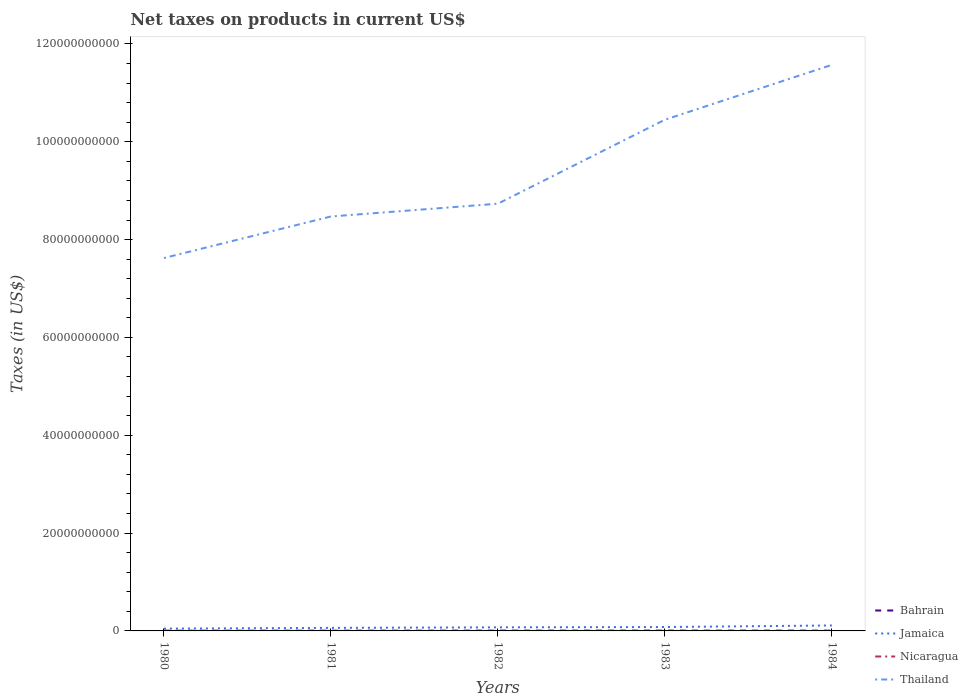Is the number of lines equal to the number of legend labels?
Your answer should be compact. Yes. Across all years, what is the maximum net taxes on products in Jamaica?
Keep it short and to the point. 4.69e+08. In which year was the net taxes on products in Bahrain maximum?
Your answer should be very brief. 1980. What is the total net taxes on products in Thailand in the graph?
Ensure brevity in your answer.  -2.84e+1. What is the difference between the highest and the second highest net taxes on products in Bahrain?
Offer a very short reply. 2.24e+07. Is the net taxes on products in Nicaragua strictly greater than the net taxes on products in Thailand over the years?
Give a very brief answer. Yes. What is the difference between two consecutive major ticks on the Y-axis?
Your answer should be very brief. 2.00e+1. Are the values on the major ticks of Y-axis written in scientific E-notation?
Offer a very short reply. No. Where does the legend appear in the graph?
Ensure brevity in your answer.  Bottom right. What is the title of the graph?
Your response must be concise. Net taxes on products in current US$. What is the label or title of the X-axis?
Your answer should be compact. Years. What is the label or title of the Y-axis?
Make the answer very short. Taxes (in US$). What is the Taxes (in US$) of Bahrain in 1980?
Keep it short and to the point. 4.03e+07. What is the Taxes (in US$) of Jamaica in 1980?
Give a very brief answer. 4.69e+08. What is the Taxes (in US$) of Nicaragua in 1980?
Your answer should be very brief. 0.15. What is the Taxes (in US$) of Thailand in 1980?
Provide a succinct answer. 7.62e+1. What is the Taxes (in US$) of Bahrain in 1981?
Offer a terse response. 5.02e+07. What is the Taxes (in US$) in Jamaica in 1981?
Your answer should be compact. 6.22e+08. What is the Taxes (in US$) of Nicaragua in 1981?
Ensure brevity in your answer.  0.54. What is the Taxes (in US$) in Thailand in 1981?
Your answer should be compact. 8.47e+1. What is the Taxes (in US$) in Bahrain in 1982?
Your answer should be very brief. 6.04e+07. What is the Taxes (in US$) in Jamaica in 1982?
Keep it short and to the point. 7.32e+08. What is the Taxes (in US$) in Nicaragua in 1982?
Keep it short and to the point. 0.74. What is the Taxes (in US$) of Thailand in 1982?
Your response must be concise. 8.73e+1. What is the Taxes (in US$) of Bahrain in 1983?
Your answer should be very brief. 6.27e+07. What is the Taxes (in US$) in Jamaica in 1983?
Keep it short and to the point. 7.94e+08. What is the Taxes (in US$) of Nicaragua in 1983?
Your answer should be very brief. 1.15. What is the Taxes (in US$) of Thailand in 1983?
Provide a succinct answer. 1.05e+11. What is the Taxes (in US$) in Bahrain in 1984?
Keep it short and to the point. 5.85e+07. What is the Taxes (in US$) of Jamaica in 1984?
Provide a succinct answer. 1.11e+09. What is the Taxes (in US$) of Nicaragua in 1984?
Provide a short and direct response. 1.9. What is the Taxes (in US$) in Thailand in 1984?
Your response must be concise. 1.16e+11. Across all years, what is the maximum Taxes (in US$) of Bahrain?
Provide a short and direct response. 6.27e+07. Across all years, what is the maximum Taxes (in US$) in Jamaica?
Keep it short and to the point. 1.11e+09. Across all years, what is the maximum Taxes (in US$) in Nicaragua?
Offer a terse response. 1.9. Across all years, what is the maximum Taxes (in US$) in Thailand?
Ensure brevity in your answer.  1.16e+11. Across all years, what is the minimum Taxes (in US$) in Bahrain?
Offer a terse response. 4.03e+07. Across all years, what is the minimum Taxes (in US$) of Jamaica?
Your answer should be very brief. 4.69e+08. Across all years, what is the minimum Taxes (in US$) in Nicaragua?
Offer a terse response. 0.15. Across all years, what is the minimum Taxes (in US$) of Thailand?
Offer a very short reply. 7.62e+1. What is the total Taxes (in US$) in Bahrain in the graph?
Your answer should be compact. 2.72e+08. What is the total Taxes (in US$) of Jamaica in the graph?
Offer a very short reply. 3.73e+09. What is the total Taxes (in US$) of Nicaragua in the graph?
Your answer should be compact. 4.48. What is the total Taxes (in US$) in Thailand in the graph?
Give a very brief answer. 4.69e+11. What is the difference between the Taxes (in US$) in Bahrain in 1980 and that in 1981?
Provide a short and direct response. -9.90e+06. What is the difference between the Taxes (in US$) in Jamaica in 1980 and that in 1981?
Keep it short and to the point. -1.53e+08. What is the difference between the Taxes (in US$) of Nicaragua in 1980 and that in 1981?
Your response must be concise. -0.39. What is the difference between the Taxes (in US$) in Thailand in 1980 and that in 1981?
Offer a terse response. -8.49e+09. What is the difference between the Taxes (in US$) in Bahrain in 1980 and that in 1982?
Provide a succinct answer. -2.01e+07. What is the difference between the Taxes (in US$) in Jamaica in 1980 and that in 1982?
Make the answer very short. -2.64e+08. What is the difference between the Taxes (in US$) in Nicaragua in 1980 and that in 1982?
Provide a short and direct response. -0.59. What is the difference between the Taxes (in US$) of Thailand in 1980 and that in 1982?
Provide a succinct answer. -1.11e+1. What is the difference between the Taxes (in US$) of Bahrain in 1980 and that in 1983?
Provide a short and direct response. -2.24e+07. What is the difference between the Taxes (in US$) of Jamaica in 1980 and that in 1983?
Offer a terse response. -3.26e+08. What is the difference between the Taxes (in US$) of Nicaragua in 1980 and that in 1983?
Make the answer very short. -1. What is the difference between the Taxes (in US$) of Thailand in 1980 and that in 1983?
Provide a short and direct response. -2.83e+1. What is the difference between the Taxes (in US$) in Bahrain in 1980 and that in 1984?
Your answer should be very brief. -1.82e+07. What is the difference between the Taxes (in US$) of Jamaica in 1980 and that in 1984?
Your answer should be compact. -6.46e+08. What is the difference between the Taxes (in US$) in Nicaragua in 1980 and that in 1984?
Offer a very short reply. -1.76. What is the difference between the Taxes (in US$) of Thailand in 1980 and that in 1984?
Ensure brevity in your answer.  -3.95e+1. What is the difference between the Taxes (in US$) of Bahrain in 1981 and that in 1982?
Your answer should be very brief. -1.02e+07. What is the difference between the Taxes (in US$) of Jamaica in 1981 and that in 1982?
Make the answer very short. -1.10e+08. What is the difference between the Taxes (in US$) of Nicaragua in 1981 and that in 1982?
Provide a short and direct response. -0.2. What is the difference between the Taxes (in US$) in Thailand in 1981 and that in 1982?
Ensure brevity in your answer.  -2.61e+09. What is the difference between the Taxes (in US$) in Bahrain in 1981 and that in 1983?
Keep it short and to the point. -1.25e+07. What is the difference between the Taxes (in US$) of Jamaica in 1981 and that in 1983?
Your response must be concise. -1.72e+08. What is the difference between the Taxes (in US$) of Nicaragua in 1981 and that in 1983?
Keep it short and to the point. -0.61. What is the difference between the Taxes (in US$) in Thailand in 1981 and that in 1983?
Keep it short and to the point. -1.98e+1. What is the difference between the Taxes (in US$) of Bahrain in 1981 and that in 1984?
Provide a succinct answer. -8.30e+06. What is the difference between the Taxes (in US$) in Jamaica in 1981 and that in 1984?
Your answer should be compact. -4.92e+08. What is the difference between the Taxes (in US$) in Nicaragua in 1981 and that in 1984?
Ensure brevity in your answer.  -1.36. What is the difference between the Taxes (in US$) in Thailand in 1981 and that in 1984?
Keep it short and to the point. -3.10e+1. What is the difference between the Taxes (in US$) in Bahrain in 1982 and that in 1983?
Offer a terse response. -2.30e+06. What is the difference between the Taxes (in US$) of Jamaica in 1982 and that in 1983?
Provide a succinct answer. -6.23e+07. What is the difference between the Taxes (in US$) in Nicaragua in 1982 and that in 1983?
Provide a succinct answer. -0.41. What is the difference between the Taxes (in US$) in Thailand in 1982 and that in 1983?
Give a very brief answer. -1.72e+1. What is the difference between the Taxes (in US$) of Bahrain in 1982 and that in 1984?
Ensure brevity in your answer.  1.90e+06. What is the difference between the Taxes (in US$) of Jamaica in 1982 and that in 1984?
Ensure brevity in your answer.  -3.82e+08. What is the difference between the Taxes (in US$) in Nicaragua in 1982 and that in 1984?
Your response must be concise. -1.16. What is the difference between the Taxes (in US$) in Thailand in 1982 and that in 1984?
Your answer should be very brief. -2.84e+1. What is the difference between the Taxes (in US$) in Bahrain in 1983 and that in 1984?
Give a very brief answer. 4.20e+06. What is the difference between the Taxes (in US$) in Jamaica in 1983 and that in 1984?
Your answer should be very brief. -3.20e+08. What is the difference between the Taxes (in US$) in Nicaragua in 1983 and that in 1984?
Ensure brevity in your answer.  -0.75. What is the difference between the Taxes (in US$) in Thailand in 1983 and that in 1984?
Provide a succinct answer. -1.12e+1. What is the difference between the Taxes (in US$) in Bahrain in 1980 and the Taxes (in US$) in Jamaica in 1981?
Keep it short and to the point. -5.82e+08. What is the difference between the Taxes (in US$) in Bahrain in 1980 and the Taxes (in US$) in Nicaragua in 1981?
Offer a very short reply. 4.03e+07. What is the difference between the Taxes (in US$) in Bahrain in 1980 and the Taxes (in US$) in Thailand in 1981?
Provide a short and direct response. -8.47e+1. What is the difference between the Taxes (in US$) of Jamaica in 1980 and the Taxes (in US$) of Nicaragua in 1981?
Your answer should be very brief. 4.69e+08. What is the difference between the Taxes (in US$) of Jamaica in 1980 and the Taxes (in US$) of Thailand in 1981?
Make the answer very short. -8.43e+1. What is the difference between the Taxes (in US$) of Nicaragua in 1980 and the Taxes (in US$) of Thailand in 1981?
Your response must be concise. -8.47e+1. What is the difference between the Taxes (in US$) in Bahrain in 1980 and the Taxes (in US$) in Jamaica in 1982?
Offer a very short reply. -6.92e+08. What is the difference between the Taxes (in US$) of Bahrain in 1980 and the Taxes (in US$) of Nicaragua in 1982?
Provide a succinct answer. 4.03e+07. What is the difference between the Taxes (in US$) in Bahrain in 1980 and the Taxes (in US$) in Thailand in 1982?
Provide a short and direct response. -8.73e+1. What is the difference between the Taxes (in US$) of Jamaica in 1980 and the Taxes (in US$) of Nicaragua in 1982?
Ensure brevity in your answer.  4.69e+08. What is the difference between the Taxes (in US$) of Jamaica in 1980 and the Taxes (in US$) of Thailand in 1982?
Ensure brevity in your answer.  -8.69e+1. What is the difference between the Taxes (in US$) in Nicaragua in 1980 and the Taxes (in US$) in Thailand in 1982?
Keep it short and to the point. -8.73e+1. What is the difference between the Taxes (in US$) in Bahrain in 1980 and the Taxes (in US$) in Jamaica in 1983?
Give a very brief answer. -7.54e+08. What is the difference between the Taxes (in US$) in Bahrain in 1980 and the Taxes (in US$) in Nicaragua in 1983?
Offer a very short reply. 4.03e+07. What is the difference between the Taxes (in US$) in Bahrain in 1980 and the Taxes (in US$) in Thailand in 1983?
Your answer should be very brief. -1.04e+11. What is the difference between the Taxes (in US$) of Jamaica in 1980 and the Taxes (in US$) of Nicaragua in 1983?
Provide a short and direct response. 4.69e+08. What is the difference between the Taxes (in US$) of Jamaica in 1980 and the Taxes (in US$) of Thailand in 1983?
Offer a terse response. -1.04e+11. What is the difference between the Taxes (in US$) in Nicaragua in 1980 and the Taxes (in US$) in Thailand in 1983?
Make the answer very short. -1.05e+11. What is the difference between the Taxes (in US$) in Bahrain in 1980 and the Taxes (in US$) in Jamaica in 1984?
Make the answer very short. -1.07e+09. What is the difference between the Taxes (in US$) in Bahrain in 1980 and the Taxes (in US$) in Nicaragua in 1984?
Offer a terse response. 4.03e+07. What is the difference between the Taxes (in US$) of Bahrain in 1980 and the Taxes (in US$) of Thailand in 1984?
Provide a short and direct response. -1.16e+11. What is the difference between the Taxes (in US$) of Jamaica in 1980 and the Taxes (in US$) of Nicaragua in 1984?
Provide a succinct answer. 4.69e+08. What is the difference between the Taxes (in US$) in Jamaica in 1980 and the Taxes (in US$) in Thailand in 1984?
Offer a very short reply. -1.15e+11. What is the difference between the Taxes (in US$) of Nicaragua in 1980 and the Taxes (in US$) of Thailand in 1984?
Your response must be concise. -1.16e+11. What is the difference between the Taxes (in US$) of Bahrain in 1981 and the Taxes (in US$) of Jamaica in 1982?
Make the answer very short. -6.82e+08. What is the difference between the Taxes (in US$) in Bahrain in 1981 and the Taxes (in US$) in Nicaragua in 1982?
Your answer should be very brief. 5.02e+07. What is the difference between the Taxes (in US$) of Bahrain in 1981 and the Taxes (in US$) of Thailand in 1982?
Give a very brief answer. -8.73e+1. What is the difference between the Taxes (in US$) in Jamaica in 1981 and the Taxes (in US$) in Nicaragua in 1982?
Your answer should be very brief. 6.22e+08. What is the difference between the Taxes (in US$) of Jamaica in 1981 and the Taxes (in US$) of Thailand in 1982?
Offer a very short reply. -8.67e+1. What is the difference between the Taxes (in US$) in Nicaragua in 1981 and the Taxes (in US$) in Thailand in 1982?
Provide a succinct answer. -8.73e+1. What is the difference between the Taxes (in US$) of Bahrain in 1981 and the Taxes (in US$) of Jamaica in 1983?
Provide a succinct answer. -7.44e+08. What is the difference between the Taxes (in US$) in Bahrain in 1981 and the Taxes (in US$) in Nicaragua in 1983?
Ensure brevity in your answer.  5.02e+07. What is the difference between the Taxes (in US$) of Bahrain in 1981 and the Taxes (in US$) of Thailand in 1983?
Ensure brevity in your answer.  -1.04e+11. What is the difference between the Taxes (in US$) of Jamaica in 1981 and the Taxes (in US$) of Nicaragua in 1983?
Make the answer very short. 6.22e+08. What is the difference between the Taxes (in US$) of Jamaica in 1981 and the Taxes (in US$) of Thailand in 1983?
Keep it short and to the point. -1.04e+11. What is the difference between the Taxes (in US$) in Nicaragua in 1981 and the Taxes (in US$) in Thailand in 1983?
Your answer should be compact. -1.05e+11. What is the difference between the Taxes (in US$) in Bahrain in 1981 and the Taxes (in US$) in Jamaica in 1984?
Your answer should be compact. -1.06e+09. What is the difference between the Taxes (in US$) in Bahrain in 1981 and the Taxes (in US$) in Nicaragua in 1984?
Offer a very short reply. 5.02e+07. What is the difference between the Taxes (in US$) of Bahrain in 1981 and the Taxes (in US$) of Thailand in 1984?
Offer a very short reply. -1.16e+11. What is the difference between the Taxes (in US$) of Jamaica in 1981 and the Taxes (in US$) of Nicaragua in 1984?
Offer a terse response. 6.22e+08. What is the difference between the Taxes (in US$) of Jamaica in 1981 and the Taxes (in US$) of Thailand in 1984?
Offer a very short reply. -1.15e+11. What is the difference between the Taxes (in US$) in Nicaragua in 1981 and the Taxes (in US$) in Thailand in 1984?
Your answer should be compact. -1.16e+11. What is the difference between the Taxes (in US$) in Bahrain in 1982 and the Taxes (in US$) in Jamaica in 1983?
Make the answer very short. -7.34e+08. What is the difference between the Taxes (in US$) in Bahrain in 1982 and the Taxes (in US$) in Nicaragua in 1983?
Your answer should be compact. 6.04e+07. What is the difference between the Taxes (in US$) of Bahrain in 1982 and the Taxes (in US$) of Thailand in 1983?
Keep it short and to the point. -1.04e+11. What is the difference between the Taxes (in US$) of Jamaica in 1982 and the Taxes (in US$) of Nicaragua in 1983?
Your response must be concise. 7.32e+08. What is the difference between the Taxes (in US$) of Jamaica in 1982 and the Taxes (in US$) of Thailand in 1983?
Provide a succinct answer. -1.04e+11. What is the difference between the Taxes (in US$) in Nicaragua in 1982 and the Taxes (in US$) in Thailand in 1983?
Offer a very short reply. -1.05e+11. What is the difference between the Taxes (in US$) of Bahrain in 1982 and the Taxes (in US$) of Jamaica in 1984?
Offer a very short reply. -1.05e+09. What is the difference between the Taxes (in US$) of Bahrain in 1982 and the Taxes (in US$) of Nicaragua in 1984?
Provide a succinct answer. 6.04e+07. What is the difference between the Taxes (in US$) of Bahrain in 1982 and the Taxes (in US$) of Thailand in 1984?
Give a very brief answer. -1.16e+11. What is the difference between the Taxes (in US$) in Jamaica in 1982 and the Taxes (in US$) in Nicaragua in 1984?
Offer a terse response. 7.32e+08. What is the difference between the Taxes (in US$) in Jamaica in 1982 and the Taxes (in US$) in Thailand in 1984?
Provide a succinct answer. -1.15e+11. What is the difference between the Taxes (in US$) of Nicaragua in 1982 and the Taxes (in US$) of Thailand in 1984?
Provide a short and direct response. -1.16e+11. What is the difference between the Taxes (in US$) in Bahrain in 1983 and the Taxes (in US$) in Jamaica in 1984?
Provide a short and direct response. -1.05e+09. What is the difference between the Taxes (in US$) of Bahrain in 1983 and the Taxes (in US$) of Nicaragua in 1984?
Offer a very short reply. 6.27e+07. What is the difference between the Taxes (in US$) of Bahrain in 1983 and the Taxes (in US$) of Thailand in 1984?
Your answer should be compact. -1.16e+11. What is the difference between the Taxes (in US$) of Jamaica in 1983 and the Taxes (in US$) of Nicaragua in 1984?
Offer a very short reply. 7.94e+08. What is the difference between the Taxes (in US$) in Jamaica in 1983 and the Taxes (in US$) in Thailand in 1984?
Give a very brief answer. -1.15e+11. What is the difference between the Taxes (in US$) in Nicaragua in 1983 and the Taxes (in US$) in Thailand in 1984?
Your response must be concise. -1.16e+11. What is the average Taxes (in US$) in Bahrain per year?
Ensure brevity in your answer.  5.44e+07. What is the average Taxes (in US$) of Jamaica per year?
Your answer should be compact. 7.46e+08. What is the average Taxes (in US$) in Nicaragua per year?
Keep it short and to the point. 0.9. What is the average Taxes (in US$) of Thailand per year?
Provide a short and direct response. 9.37e+1. In the year 1980, what is the difference between the Taxes (in US$) of Bahrain and Taxes (in US$) of Jamaica?
Provide a short and direct response. -4.28e+08. In the year 1980, what is the difference between the Taxes (in US$) of Bahrain and Taxes (in US$) of Nicaragua?
Offer a very short reply. 4.03e+07. In the year 1980, what is the difference between the Taxes (in US$) of Bahrain and Taxes (in US$) of Thailand?
Keep it short and to the point. -7.62e+1. In the year 1980, what is the difference between the Taxes (in US$) in Jamaica and Taxes (in US$) in Nicaragua?
Keep it short and to the point. 4.69e+08. In the year 1980, what is the difference between the Taxes (in US$) of Jamaica and Taxes (in US$) of Thailand?
Offer a very short reply. -7.58e+1. In the year 1980, what is the difference between the Taxes (in US$) in Nicaragua and Taxes (in US$) in Thailand?
Offer a very short reply. -7.62e+1. In the year 1981, what is the difference between the Taxes (in US$) of Bahrain and Taxes (in US$) of Jamaica?
Provide a short and direct response. -5.72e+08. In the year 1981, what is the difference between the Taxes (in US$) in Bahrain and Taxes (in US$) in Nicaragua?
Give a very brief answer. 5.02e+07. In the year 1981, what is the difference between the Taxes (in US$) in Bahrain and Taxes (in US$) in Thailand?
Your answer should be compact. -8.47e+1. In the year 1981, what is the difference between the Taxes (in US$) in Jamaica and Taxes (in US$) in Nicaragua?
Ensure brevity in your answer.  6.22e+08. In the year 1981, what is the difference between the Taxes (in US$) of Jamaica and Taxes (in US$) of Thailand?
Your answer should be compact. -8.41e+1. In the year 1981, what is the difference between the Taxes (in US$) in Nicaragua and Taxes (in US$) in Thailand?
Give a very brief answer. -8.47e+1. In the year 1982, what is the difference between the Taxes (in US$) of Bahrain and Taxes (in US$) of Jamaica?
Ensure brevity in your answer.  -6.72e+08. In the year 1982, what is the difference between the Taxes (in US$) of Bahrain and Taxes (in US$) of Nicaragua?
Offer a very short reply. 6.04e+07. In the year 1982, what is the difference between the Taxes (in US$) of Bahrain and Taxes (in US$) of Thailand?
Your answer should be very brief. -8.73e+1. In the year 1982, what is the difference between the Taxes (in US$) of Jamaica and Taxes (in US$) of Nicaragua?
Ensure brevity in your answer.  7.32e+08. In the year 1982, what is the difference between the Taxes (in US$) in Jamaica and Taxes (in US$) in Thailand?
Your answer should be compact. -8.66e+1. In the year 1982, what is the difference between the Taxes (in US$) of Nicaragua and Taxes (in US$) of Thailand?
Offer a terse response. -8.73e+1. In the year 1983, what is the difference between the Taxes (in US$) of Bahrain and Taxes (in US$) of Jamaica?
Provide a succinct answer. -7.32e+08. In the year 1983, what is the difference between the Taxes (in US$) of Bahrain and Taxes (in US$) of Nicaragua?
Keep it short and to the point. 6.27e+07. In the year 1983, what is the difference between the Taxes (in US$) in Bahrain and Taxes (in US$) in Thailand?
Offer a very short reply. -1.04e+11. In the year 1983, what is the difference between the Taxes (in US$) in Jamaica and Taxes (in US$) in Nicaragua?
Your answer should be very brief. 7.94e+08. In the year 1983, what is the difference between the Taxes (in US$) of Jamaica and Taxes (in US$) of Thailand?
Your answer should be compact. -1.04e+11. In the year 1983, what is the difference between the Taxes (in US$) of Nicaragua and Taxes (in US$) of Thailand?
Offer a very short reply. -1.05e+11. In the year 1984, what is the difference between the Taxes (in US$) of Bahrain and Taxes (in US$) of Jamaica?
Give a very brief answer. -1.06e+09. In the year 1984, what is the difference between the Taxes (in US$) in Bahrain and Taxes (in US$) in Nicaragua?
Ensure brevity in your answer.  5.85e+07. In the year 1984, what is the difference between the Taxes (in US$) of Bahrain and Taxes (in US$) of Thailand?
Ensure brevity in your answer.  -1.16e+11. In the year 1984, what is the difference between the Taxes (in US$) in Jamaica and Taxes (in US$) in Nicaragua?
Make the answer very short. 1.11e+09. In the year 1984, what is the difference between the Taxes (in US$) of Jamaica and Taxes (in US$) of Thailand?
Provide a short and direct response. -1.15e+11. In the year 1984, what is the difference between the Taxes (in US$) of Nicaragua and Taxes (in US$) of Thailand?
Provide a short and direct response. -1.16e+11. What is the ratio of the Taxes (in US$) in Bahrain in 1980 to that in 1981?
Provide a succinct answer. 0.8. What is the ratio of the Taxes (in US$) of Jamaica in 1980 to that in 1981?
Make the answer very short. 0.75. What is the ratio of the Taxes (in US$) in Nicaragua in 1980 to that in 1981?
Offer a very short reply. 0.28. What is the ratio of the Taxes (in US$) in Thailand in 1980 to that in 1981?
Offer a very short reply. 0.9. What is the ratio of the Taxes (in US$) of Bahrain in 1980 to that in 1982?
Give a very brief answer. 0.67. What is the ratio of the Taxes (in US$) in Jamaica in 1980 to that in 1982?
Make the answer very short. 0.64. What is the ratio of the Taxes (in US$) in Nicaragua in 1980 to that in 1982?
Provide a short and direct response. 0.2. What is the ratio of the Taxes (in US$) in Thailand in 1980 to that in 1982?
Make the answer very short. 0.87. What is the ratio of the Taxes (in US$) of Bahrain in 1980 to that in 1983?
Ensure brevity in your answer.  0.64. What is the ratio of the Taxes (in US$) in Jamaica in 1980 to that in 1983?
Give a very brief answer. 0.59. What is the ratio of the Taxes (in US$) in Nicaragua in 1980 to that in 1983?
Provide a succinct answer. 0.13. What is the ratio of the Taxes (in US$) in Thailand in 1980 to that in 1983?
Provide a succinct answer. 0.73. What is the ratio of the Taxes (in US$) in Bahrain in 1980 to that in 1984?
Give a very brief answer. 0.69. What is the ratio of the Taxes (in US$) of Jamaica in 1980 to that in 1984?
Make the answer very short. 0.42. What is the ratio of the Taxes (in US$) in Nicaragua in 1980 to that in 1984?
Provide a succinct answer. 0.08. What is the ratio of the Taxes (in US$) of Thailand in 1980 to that in 1984?
Keep it short and to the point. 0.66. What is the ratio of the Taxes (in US$) in Bahrain in 1981 to that in 1982?
Give a very brief answer. 0.83. What is the ratio of the Taxes (in US$) in Jamaica in 1981 to that in 1982?
Offer a very short reply. 0.85. What is the ratio of the Taxes (in US$) in Nicaragua in 1981 to that in 1982?
Provide a succinct answer. 0.73. What is the ratio of the Taxes (in US$) in Thailand in 1981 to that in 1982?
Give a very brief answer. 0.97. What is the ratio of the Taxes (in US$) in Bahrain in 1981 to that in 1983?
Offer a terse response. 0.8. What is the ratio of the Taxes (in US$) in Jamaica in 1981 to that in 1983?
Keep it short and to the point. 0.78. What is the ratio of the Taxes (in US$) of Nicaragua in 1981 to that in 1983?
Give a very brief answer. 0.47. What is the ratio of the Taxes (in US$) of Thailand in 1981 to that in 1983?
Give a very brief answer. 0.81. What is the ratio of the Taxes (in US$) of Bahrain in 1981 to that in 1984?
Your answer should be very brief. 0.86. What is the ratio of the Taxes (in US$) of Jamaica in 1981 to that in 1984?
Provide a short and direct response. 0.56. What is the ratio of the Taxes (in US$) of Nicaragua in 1981 to that in 1984?
Your answer should be very brief. 0.28. What is the ratio of the Taxes (in US$) in Thailand in 1981 to that in 1984?
Give a very brief answer. 0.73. What is the ratio of the Taxes (in US$) in Bahrain in 1982 to that in 1983?
Offer a very short reply. 0.96. What is the ratio of the Taxes (in US$) of Jamaica in 1982 to that in 1983?
Offer a very short reply. 0.92. What is the ratio of the Taxes (in US$) in Nicaragua in 1982 to that in 1983?
Your response must be concise. 0.64. What is the ratio of the Taxes (in US$) in Thailand in 1982 to that in 1983?
Provide a short and direct response. 0.84. What is the ratio of the Taxes (in US$) in Bahrain in 1982 to that in 1984?
Make the answer very short. 1.03. What is the ratio of the Taxes (in US$) of Jamaica in 1982 to that in 1984?
Provide a short and direct response. 0.66. What is the ratio of the Taxes (in US$) in Nicaragua in 1982 to that in 1984?
Provide a succinct answer. 0.39. What is the ratio of the Taxes (in US$) of Thailand in 1982 to that in 1984?
Make the answer very short. 0.75. What is the ratio of the Taxes (in US$) of Bahrain in 1983 to that in 1984?
Give a very brief answer. 1.07. What is the ratio of the Taxes (in US$) of Jamaica in 1983 to that in 1984?
Ensure brevity in your answer.  0.71. What is the ratio of the Taxes (in US$) in Nicaragua in 1983 to that in 1984?
Ensure brevity in your answer.  0.6. What is the ratio of the Taxes (in US$) of Thailand in 1983 to that in 1984?
Provide a short and direct response. 0.9. What is the difference between the highest and the second highest Taxes (in US$) of Bahrain?
Provide a succinct answer. 2.30e+06. What is the difference between the highest and the second highest Taxes (in US$) in Jamaica?
Provide a succinct answer. 3.20e+08. What is the difference between the highest and the second highest Taxes (in US$) in Nicaragua?
Your response must be concise. 0.75. What is the difference between the highest and the second highest Taxes (in US$) in Thailand?
Offer a terse response. 1.12e+1. What is the difference between the highest and the lowest Taxes (in US$) in Bahrain?
Your answer should be very brief. 2.24e+07. What is the difference between the highest and the lowest Taxes (in US$) of Jamaica?
Offer a terse response. 6.46e+08. What is the difference between the highest and the lowest Taxes (in US$) in Nicaragua?
Your answer should be compact. 1.76. What is the difference between the highest and the lowest Taxes (in US$) in Thailand?
Offer a terse response. 3.95e+1. 